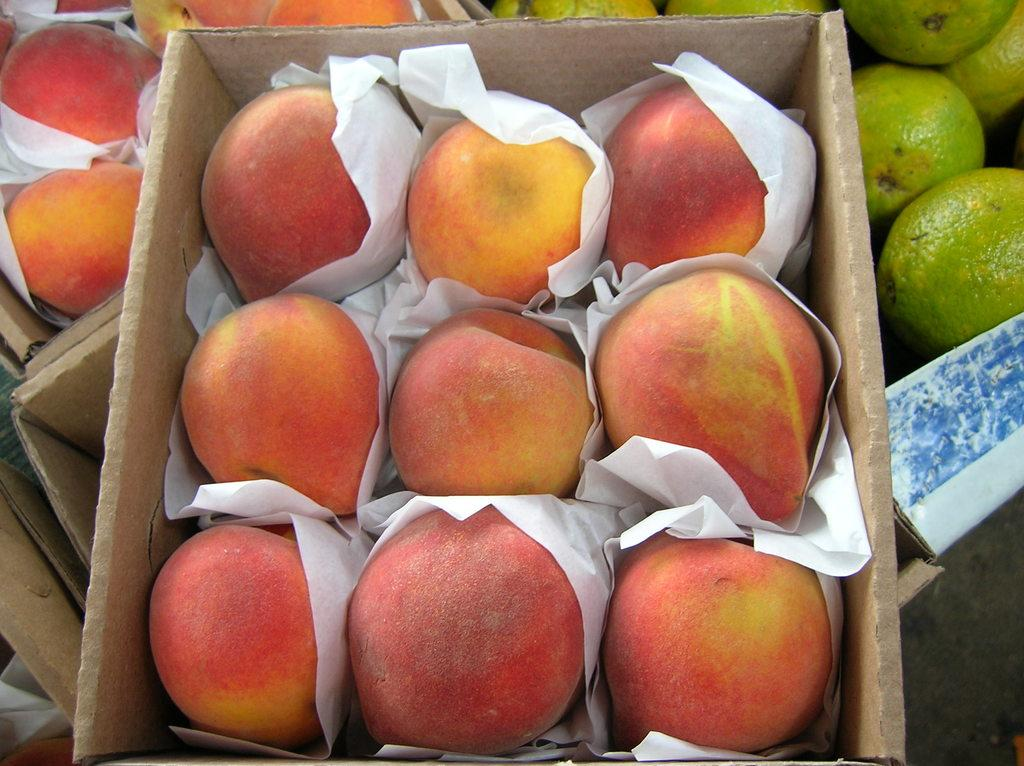What objects are present in the image? There are boxes and papers in the image. What is inside the boxes? The boxes contain fruits. What type of cap is being used to mix the powder in the image? There is no cap or powder present in the image; it only contains boxes and papers. 